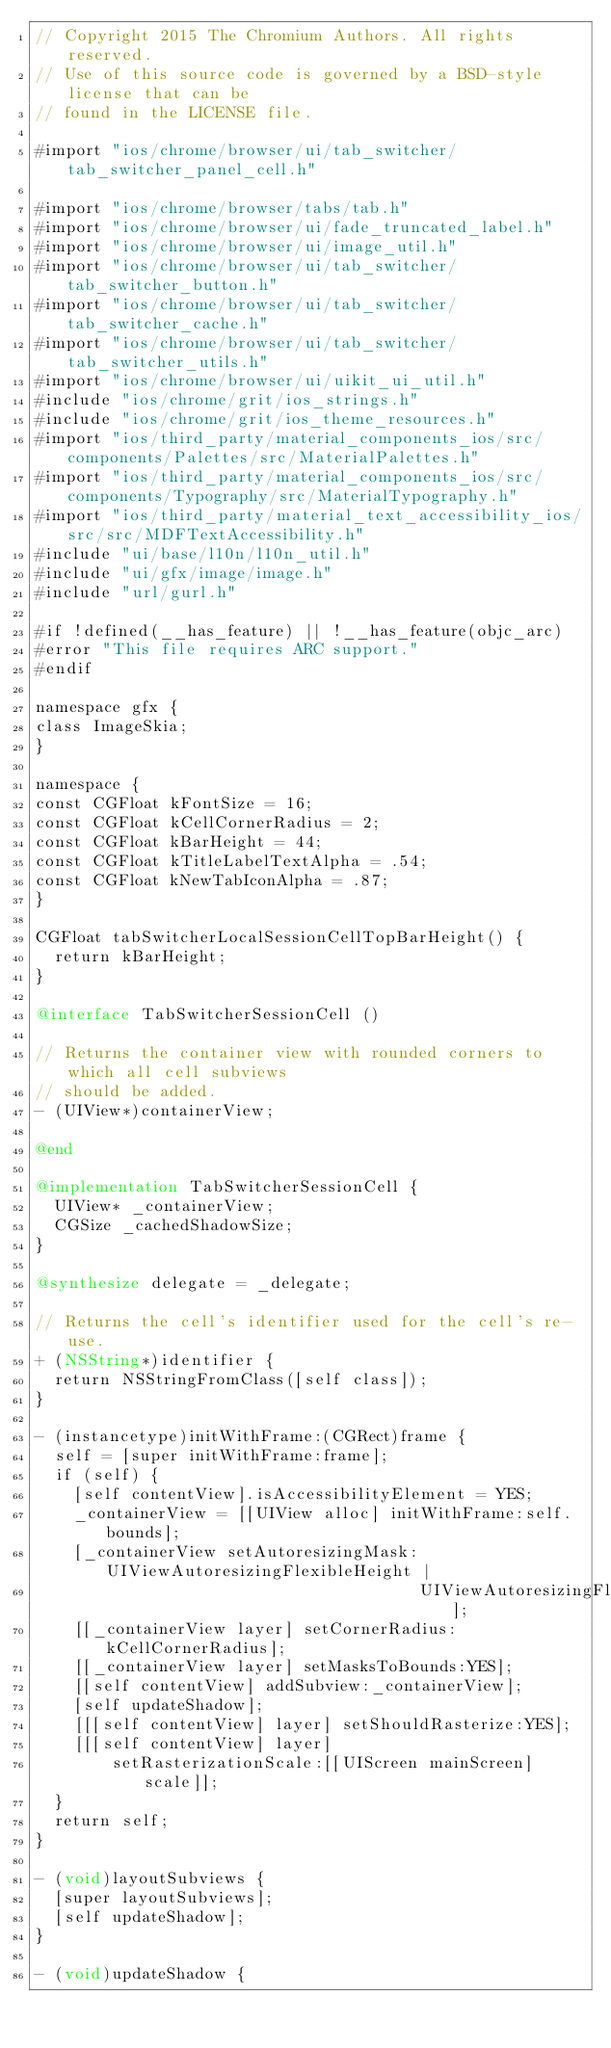<code> <loc_0><loc_0><loc_500><loc_500><_ObjectiveC_>// Copyright 2015 The Chromium Authors. All rights reserved.
// Use of this source code is governed by a BSD-style license that can be
// found in the LICENSE file.

#import "ios/chrome/browser/ui/tab_switcher/tab_switcher_panel_cell.h"

#import "ios/chrome/browser/tabs/tab.h"
#import "ios/chrome/browser/ui/fade_truncated_label.h"
#import "ios/chrome/browser/ui/image_util.h"
#import "ios/chrome/browser/ui/tab_switcher/tab_switcher_button.h"
#import "ios/chrome/browser/ui/tab_switcher/tab_switcher_cache.h"
#import "ios/chrome/browser/ui/tab_switcher/tab_switcher_utils.h"
#import "ios/chrome/browser/ui/uikit_ui_util.h"
#include "ios/chrome/grit/ios_strings.h"
#include "ios/chrome/grit/ios_theme_resources.h"
#import "ios/third_party/material_components_ios/src/components/Palettes/src/MaterialPalettes.h"
#import "ios/third_party/material_components_ios/src/components/Typography/src/MaterialTypography.h"
#import "ios/third_party/material_text_accessibility_ios/src/src/MDFTextAccessibility.h"
#include "ui/base/l10n/l10n_util.h"
#include "ui/gfx/image/image.h"
#include "url/gurl.h"

#if !defined(__has_feature) || !__has_feature(objc_arc)
#error "This file requires ARC support."
#endif

namespace gfx {
class ImageSkia;
}

namespace {
const CGFloat kFontSize = 16;
const CGFloat kCellCornerRadius = 2;
const CGFloat kBarHeight = 44;
const CGFloat kTitleLabelTextAlpha = .54;
const CGFloat kNewTabIconAlpha = .87;
}

CGFloat tabSwitcherLocalSessionCellTopBarHeight() {
  return kBarHeight;
}

@interface TabSwitcherSessionCell ()

// Returns the container view with rounded corners to which all cell subviews
// should be added.
- (UIView*)containerView;

@end

@implementation TabSwitcherSessionCell {
  UIView* _containerView;
  CGSize _cachedShadowSize;
}

@synthesize delegate = _delegate;

// Returns the cell's identifier used for the cell's re-use.
+ (NSString*)identifier {
  return NSStringFromClass([self class]);
}

- (instancetype)initWithFrame:(CGRect)frame {
  self = [super initWithFrame:frame];
  if (self) {
    [self contentView].isAccessibilityElement = YES;
    _containerView = [[UIView alloc] initWithFrame:self.bounds];
    [_containerView setAutoresizingMask:UIViewAutoresizingFlexibleHeight |
                                        UIViewAutoresizingFlexibleWidth];
    [[_containerView layer] setCornerRadius:kCellCornerRadius];
    [[_containerView layer] setMasksToBounds:YES];
    [[self contentView] addSubview:_containerView];
    [self updateShadow];
    [[[self contentView] layer] setShouldRasterize:YES];
    [[[self contentView] layer]
        setRasterizationScale:[[UIScreen mainScreen] scale]];
  }
  return self;
}

- (void)layoutSubviews {
  [super layoutSubviews];
  [self updateShadow];
}

- (void)updateShadow {</code> 